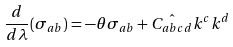<formula> <loc_0><loc_0><loc_500><loc_500>\frac { d } { d \lambda } ( { \sigma } _ { a b } ) = - { \theta } { \sigma } _ { a b } + \hat { C _ { a b c d } } k ^ { c } k ^ { d }</formula> 